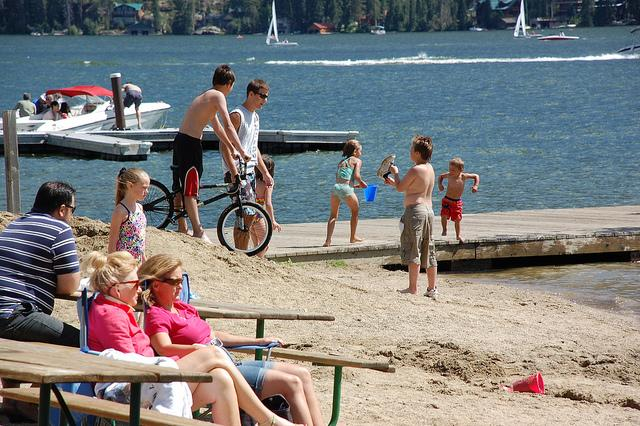Why is the boy holding up his shoe?

Choices:
A) disposing sand
B) avoiding water
C) beating people
D) tying shoe disposing sand 